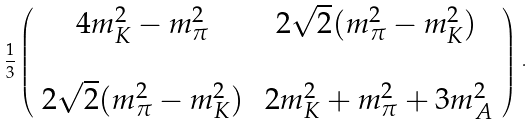Convert formula to latex. <formula><loc_0><loc_0><loc_500><loc_500>\frac { 1 } { 3 } \left ( \begin{array} { c c } 4 m _ { K } ^ { 2 } - m _ { \pi } ^ { 2 } & 2 \sqrt { 2 } ( m _ { \pi } ^ { 2 } - m _ { K } ^ { 2 } ) \\ & \\ 2 \sqrt { 2 } ( m _ { \pi } ^ { 2 } - m _ { K } ^ { 2 } ) & \, 2 m _ { K } ^ { 2 } + m _ { \pi } ^ { 2 } + 3 m _ { A } ^ { 2 } \end{array} \right ) \, .</formula> 